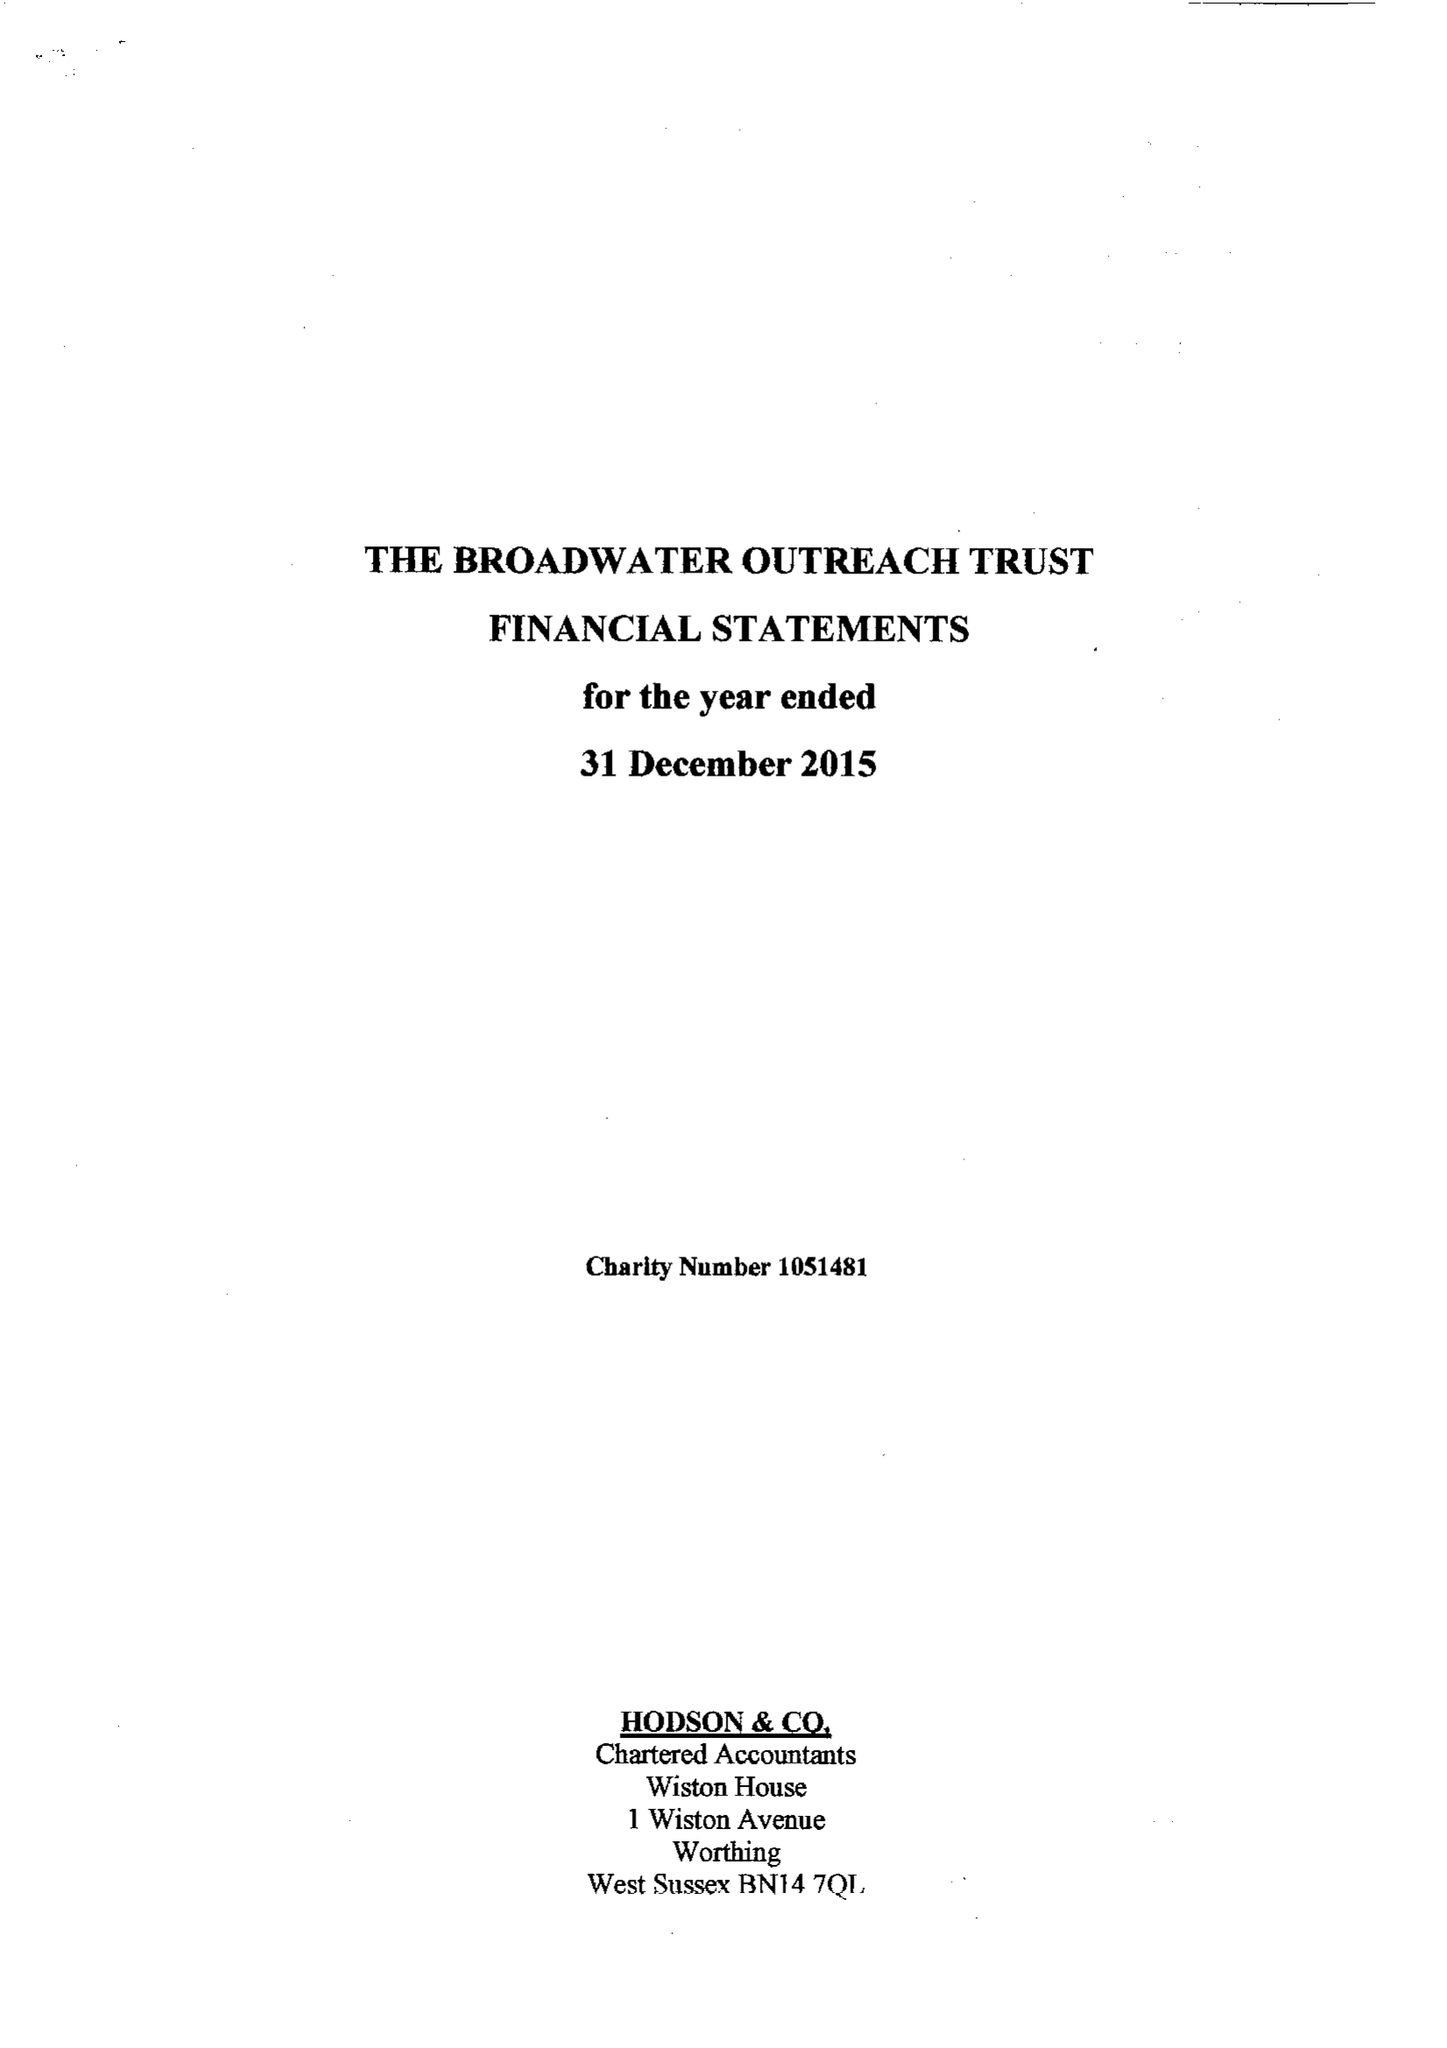What is the value for the address__postcode?
Answer the question using a single word or phrase. BN14 8HT 